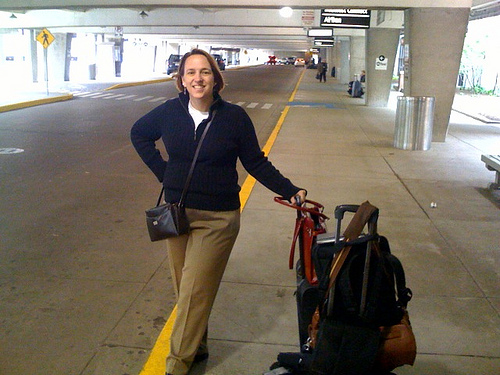What might be the woman's destination or reason for travel? The woman could be traveling for numerous reasons. Perhaps she is heading on a vacation to visit loved ones, or maybe she is on a business trip. Given her relaxed posture and smile, it seems like this trip is something she looks forward to, indicating a personal or recreational journey. Could you describe what stands out about her choice of luggage? Certainly! The woman is traveling with a combination of a large suitcase and a smaller handbag. The large suitcase is black and seems durable for travel, while her handbag is more for convenient access to personal items. Her choice suggests she has packed methodically for a long enough stay to warrant a sizable suitcase. 